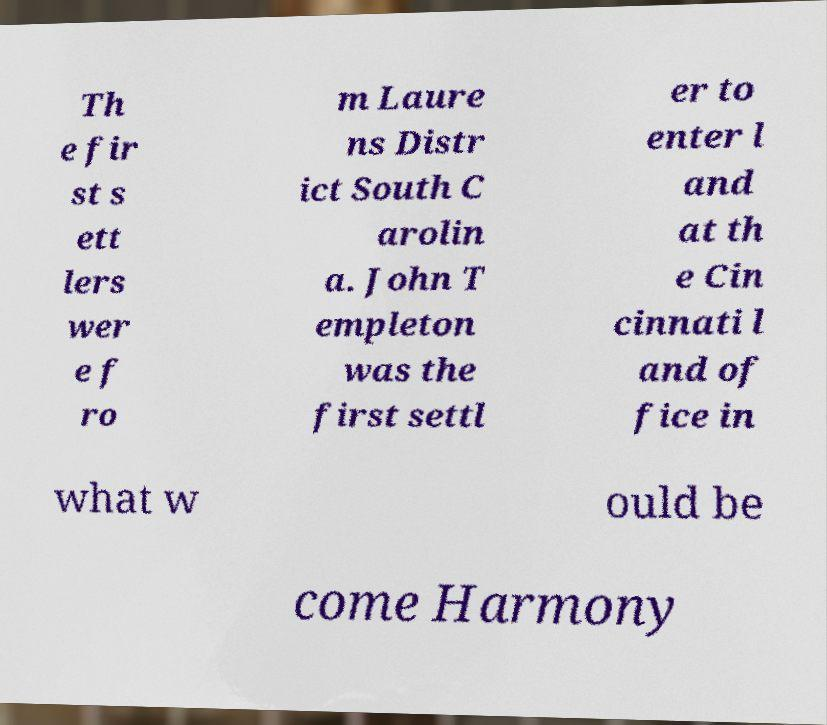For documentation purposes, I need the text within this image transcribed. Could you provide that? Th e fir st s ett lers wer e f ro m Laure ns Distr ict South C arolin a. John T empleton was the first settl er to enter l and at th e Cin cinnati l and of fice in what w ould be come Harmony 